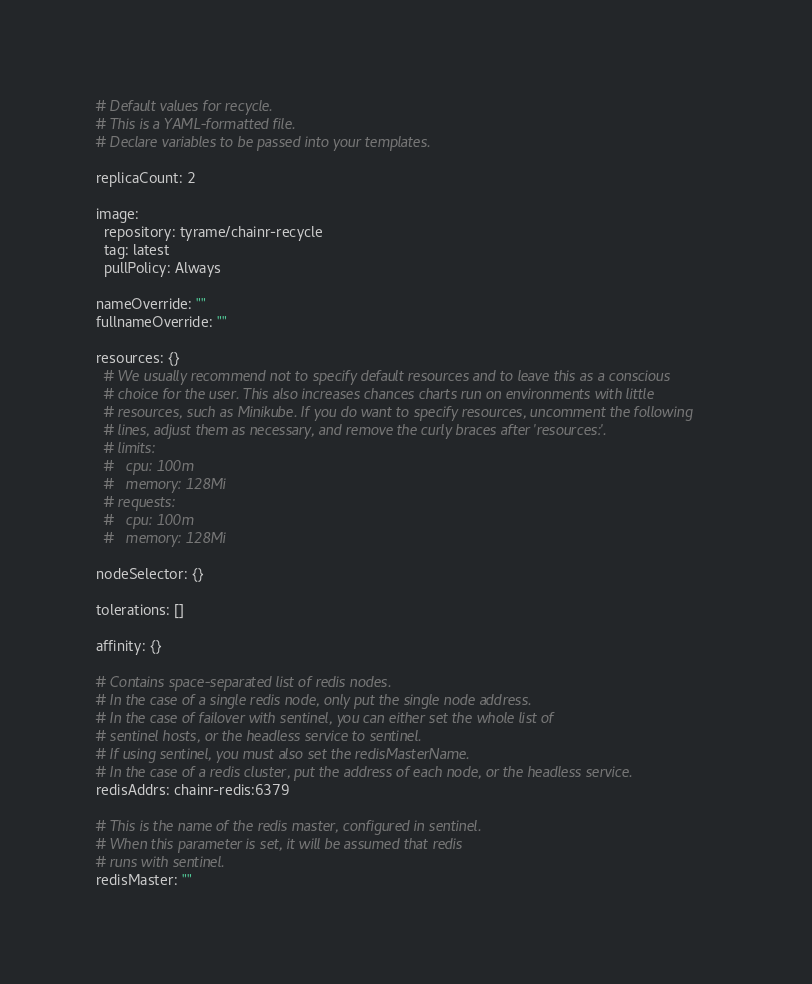Convert code to text. <code><loc_0><loc_0><loc_500><loc_500><_YAML_># Default values for recycle.
# This is a YAML-formatted file.
# Declare variables to be passed into your templates.

replicaCount: 2

image:
  repository: tyrame/chainr-recycle
  tag: latest
  pullPolicy: Always

nameOverride: ""
fullnameOverride: ""

resources: {}
  # We usually recommend not to specify default resources and to leave this as a conscious
  # choice for the user. This also increases chances charts run on environments with little
  # resources, such as Minikube. If you do want to specify resources, uncomment the following
  # lines, adjust them as necessary, and remove the curly braces after 'resources:'.
  # limits:
  #   cpu: 100m
  #   memory: 128Mi
  # requests:
  #   cpu: 100m
  #   memory: 128Mi

nodeSelector: {}

tolerations: []

affinity: {}

# Contains space-separated list of redis nodes.
# In the case of a single redis node, only put the single node address.
# In the case of failover with sentinel, you can either set the whole list of
# sentinel hosts, or the headless service to sentinel.
# If using sentinel, you must also set the redisMasterName.
# In the case of a redis cluster, put the address of each node, or the headless service.
redisAddrs: chainr-redis:6379

# This is the name of the redis master, configured in sentinel.
# When this parameter is set, it will be assumed that redis
# runs with sentinel.
redisMaster: ""
</code> 